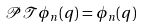Convert formula to latex. <formula><loc_0><loc_0><loc_500><loc_500>\mathcal { P T } \phi _ { n } ( q ) = \phi _ { n } ( q )</formula> 